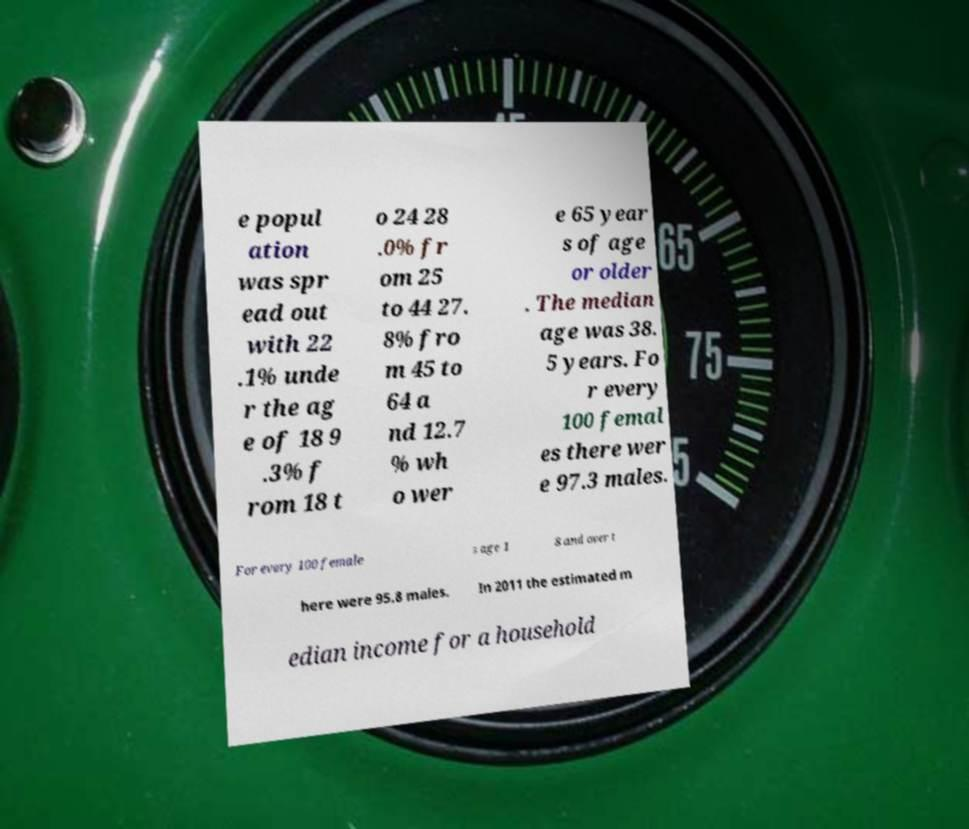Please identify and transcribe the text found in this image. e popul ation was spr ead out with 22 .1% unde r the ag e of 18 9 .3% f rom 18 t o 24 28 .0% fr om 25 to 44 27. 8% fro m 45 to 64 a nd 12.7 % wh o wer e 65 year s of age or older . The median age was 38. 5 years. Fo r every 100 femal es there wer e 97.3 males. For every 100 female s age 1 8 and over t here were 95.8 males. In 2011 the estimated m edian income for a household 